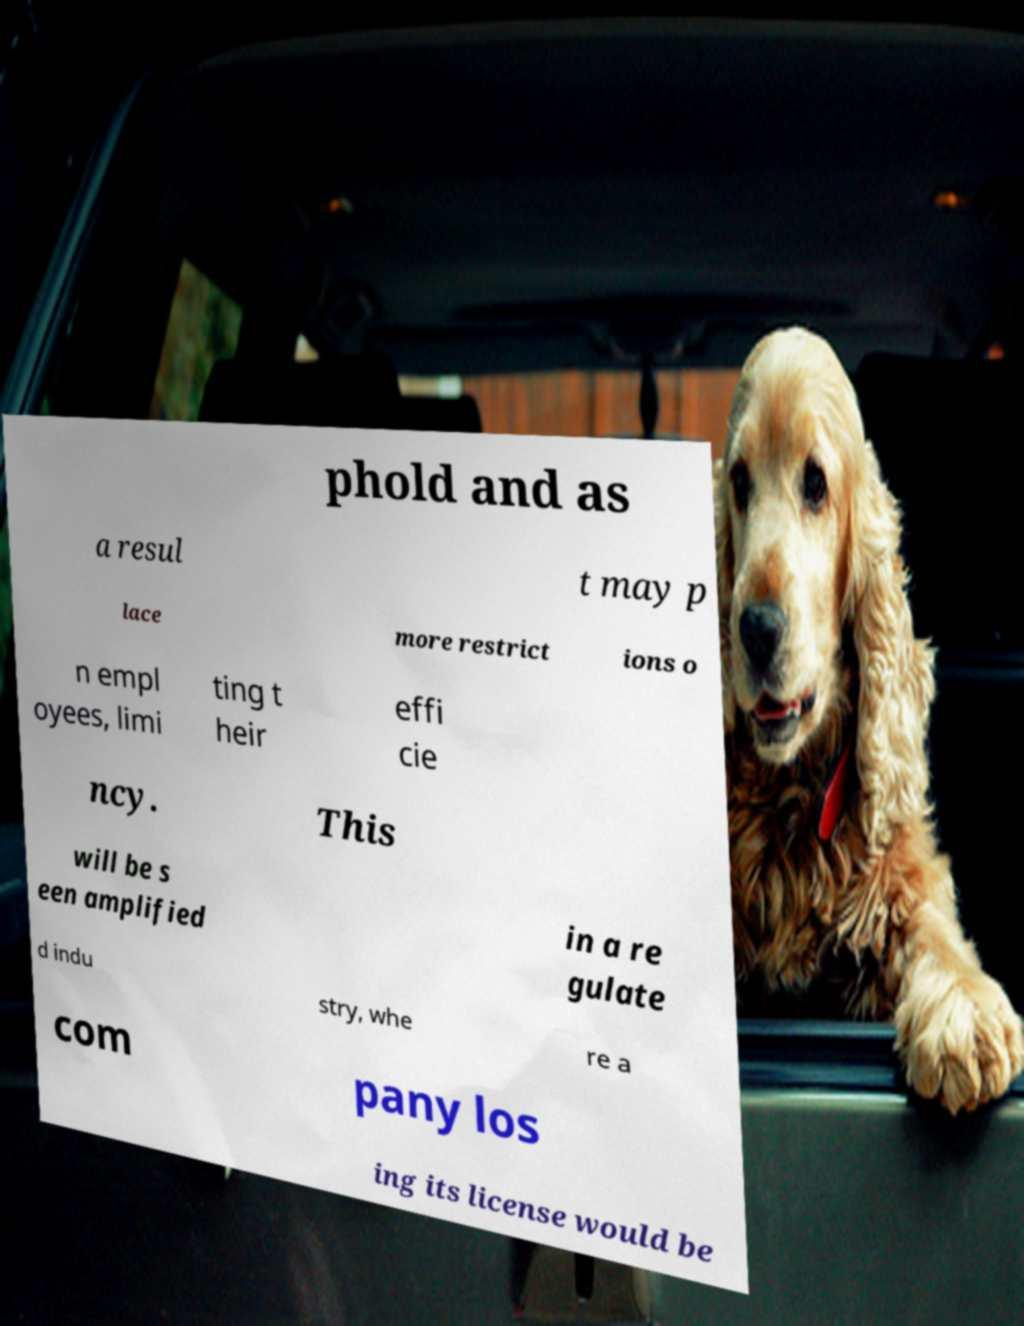Can you accurately transcribe the text from the provided image for me? phold and as a resul t may p lace more restrict ions o n empl oyees, limi ting t heir effi cie ncy. This will be s een amplified in a re gulate d indu stry, whe re a com pany los ing its license would be 